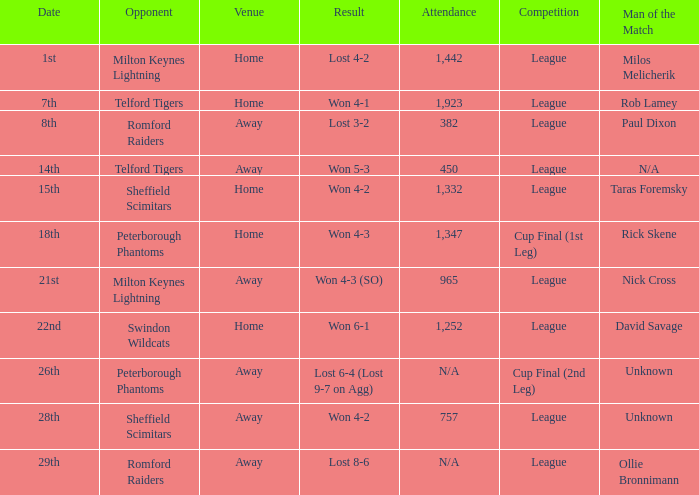On what date was the venue Away and the result was lost 6-4 (lost 9-7 on agg)? 26th. 